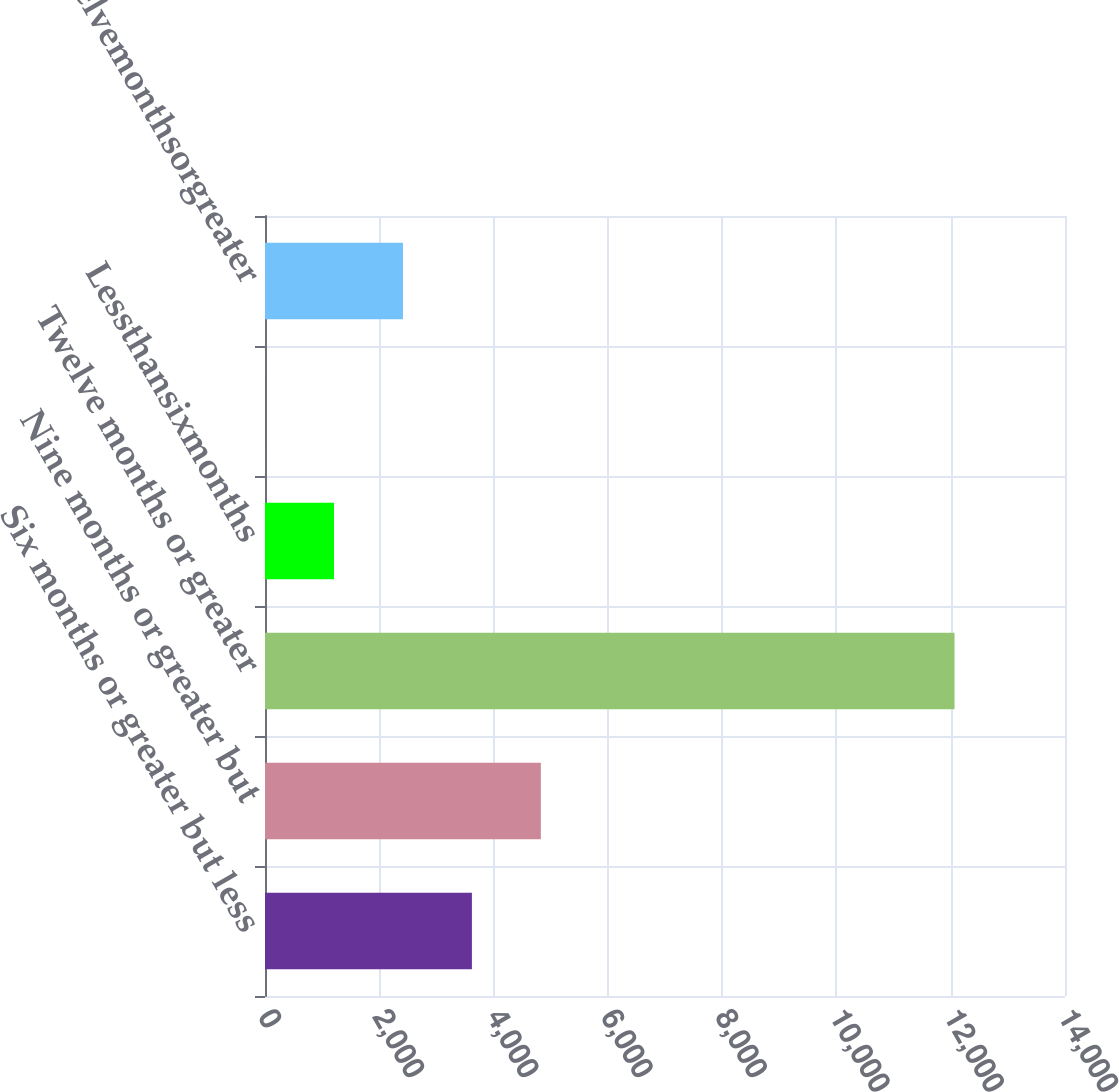<chart> <loc_0><loc_0><loc_500><loc_500><bar_chart><fcel>Six months or greater but less<fcel>Nine months or greater but<fcel>Twelve months or greater<fcel>Lessthansixmonths<fcel>Unnamed: 4<fcel>Twelvemonthsorgreater<nl><fcel>3620.8<fcel>4827.4<fcel>12067<fcel>1207.6<fcel>1<fcel>2414.2<nl></chart> 